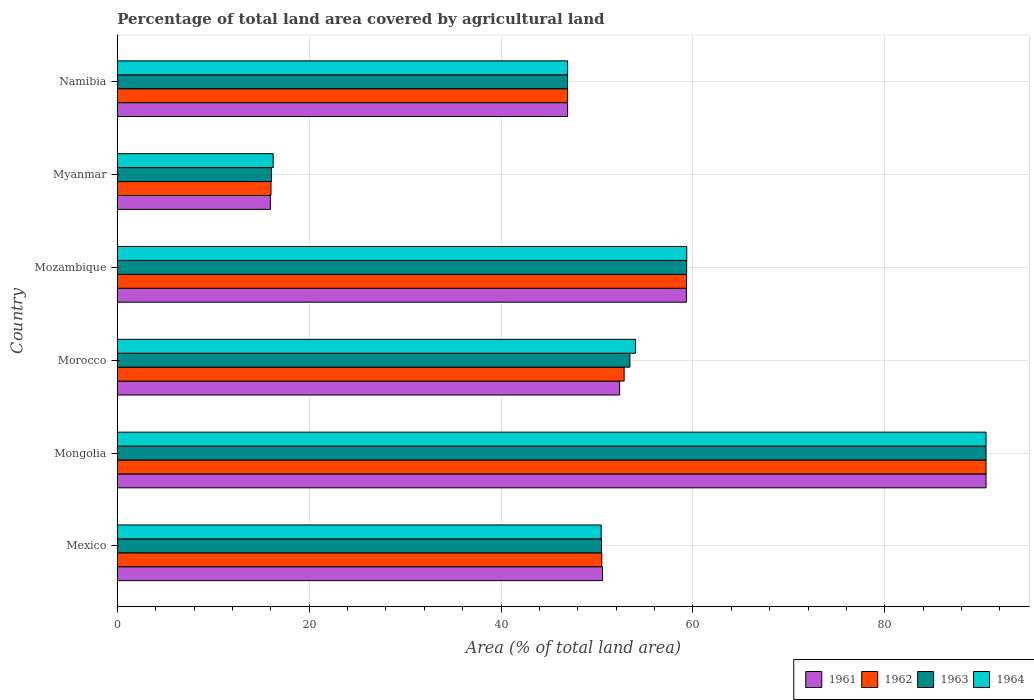How many different coloured bars are there?
Your answer should be very brief. 4. How many groups of bars are there?
Your answer should be very brief. 6. Are the number of bars per tick equal to the number of legend labels?
Your answer should be very brief. Yes. Are the number of bars on each tick of the Y-axis equal?
Provide a short and direct response. Yes. How many bars are there on the 2nd tick from the top?
Your answer should be compact. 4. What is the label of the 2nd group of bars from the top?
Provide a succinct answer. Myanmar. In how many cases, is the number of bars for a given country not equal to the number of legend labels?
Provide a short and direct response. 0. What is the percentage of agricultural land in 1962 in Namibia?
Offer a very short reply. 46.94. Across all countries, what is the maximum percentage of agricultural land in 1962?
Offer a very short reply. 90.56. Across all countries, what is the minimum percentage of agricultural land in 1963?
Your answer should be compact. 16.08. In which country was the percentage of agricultural land in 1962 maximum?
Give a very brief answer. Mongolia. In which country was the percentage of agricultural land in 1962 minimum?
Your response must be concise. Myanmar. What is the total percentage of agricultural land in 1961 in the graph?
Offer a terse response. 315.71. What is the difference between the percentage of agricultural land in 1961 in Mozambique and that in Myanmar?
Ensure brevity in your answer.  43.36. What is the difference between the percentage of agricultural land in 1962 in Mozambique and the percentage of agricultural land in 1961 in Mongolia?
Keep it short and to the point. -31.22. What is the average percentage of agricultural land in 1964 per country?
Your answer should be very brief. 52.93. What is the difference between the percentage of agricultural land in 1962 and percentage of agricultural land in 1961 in Myanmar?
Your response must be concise. 0.06. In how many countries, is the percentage of agricultural land in 1962 greater than 48 %?
Ensure brevity in your answer.  4. What is the ratio of the percentage of agricultural land in 1961 in Mexico to that in Mongolia?
Offer a terse response. 0.56. Is the percentage of agricultural land in 1961 in Mozambique less than that in Myanmar?
Make the answer very short. No. What is the difference between the highest and the second highest percentage of agricultural land in 1964?
Keep it short and to the point. 31.2. What is the difference between the highest and the lowest percentage of agricultural land in 1962?
Your response must be concise. 74.53. What does the 4th bar from the top in Morocco represents?
Keep it short and to the point. 1961. Is it the case that in every country, the sum of the percentage of agricultural land in 1962 and percentage of agricultural land in 1963 is greater than the percentage of agricultural land in 1961?
Your answer should be compact. Yes. Are the values on the major ticks of X-axis written in scientific E-notation?
Offer a very short reply. No. Where does the legend appear in the graph?
Offer a very short reply. Bottom right. How many legend labels are there?
Offer a very short reply. 4. How are the legend labels stacked?
Your response must be concise. Horizontal. What is the title of the graph?
Provide a succinct answer. Percentage of total land area covered by agricultural land. Does "1976" appear as one of the legend labels in the graph?
Ensure brevity in your answer.  No. What is the label or title of the X-axis?
Make the answer very short. Area (% of total land area). What is the Area (% of total land area) in 1961 in Mexico?
Offer a terse response. 50.58. What is the Area (% of total land area) of 1962 in Mexico?
Your response must be concise. 50.5. What is the Area (% of total land area) in 1963 in Mexico?
Ensure brevity in your answer.  50.47. What is the Area (% of total land area) in 1964 in Mexico?
Make the answer very short. 50.44. What is the Area (% of total land area) of 1961 in Mongolia?
Your answer should be compact. 90.56. What is the Area (% of total land area) of 1962 in Mongolia?
Offer a very short reply. 90.56. What is the Area (% of total land area) of 1963 in Mongolia?
Your response must be concise. 90.56. What is the Area (% of total land area) in 1964 in Mongolia?
Make the answer very short. 90.55. What is the Area (% of total land area) of 1961 in Morocco?
Provide a succinct answer. 52.36. What is the Area (% of total land area) in 1962 in Morocco?
Offer a terse response. 52.83. What is the Area (% of total land area) of 1963 in Morocco?
Make the answer very short. 53.43. What is the Area (% of total land area) in 1964 in Morocco?
Give a very brief answer. 54.02. What is the Area (% of total land area) of 1961 in Mozambique?
Provide a short and direct response. 59.32. What is the Area (% of total land area) of 1962 in Mozambique?
Give a very brief answer. 59.34. What is the Area (% of total land area) of 1963 in Mozambique?
Your response must be concise. 59.35. What is the Area (% of total land area) of 1964 in Mozambique?
Your answer should be very brief. 59.36. What is the Area (% of total land area) of 1961 in Myanmar?
Your answer should be compact. 15.96. What is the Area (% of total land area) of 1962 in Myanmar?
Your response must be concise. 16.02. What is the Area (% of total land area) of 1963 in Myanmar?
Offer a terse response. 16.08. What is the Area (% of total land area) of 1964 in Myanmar?
Your answer should be very brief. 16.25. What is the Area (% of total land area) in 1961 in Namibia?
Your answer should be compact. 46.94. What is the Area (% of total land area) in 1962 in Namibia?
Provide a short and direct response. 46.94. What is the Area (% of total land area) in 1963 in Namibia?
Provide a succinct answer. 46.94. What is the Area (% of total land area) of 1964 in Namibia?
Offer a very short reply. 46.94. Across all countries, what is the maximum Area (% of total land area) in 1961?
Offer a very short reply. 90.56. Across all countries, what is the maximum Area (% of total land area) of 1962?
Offer a terse response. 90.56. Across all countries, what is the maximum Area (% of total land area) in 1963?
Offer a terse response. 90.56. Across all countries, what is the maximum Area (% of total land area) in 1964?
Keep it short and to the point. 90.55. Across all countries, what is the minimum Area (% of total land area) of 1961?
Your answer should be very brief. 15.96. Across all countries, what is the minimum Area (% of total land area) of 1962?
Make the answer very short. 16.02. Across all countries, what is the minimum Area (% of total land area) in 1963?
Make the answer very short. 16.08. Across all countries, what is the minimum Area (% of total land area) in 1964?
Keep it short and to the point. 16.25. What is the total Area (% of total land area) of 1961 in the graph?
Your answer should be very brief. 315.71. What is the total Area (% of total land area) in 1962 in the graph?
Provide a succinct answer. 316.18. What is the total Area (% of total land area) of 1963 in the graph?
Make the answer very short. 316.82. What is the total Area (% of total land area) of 1964 in the graph?
Ensure brevity in your answer.  317.56. What is the difference between the Area (% of total land area) of 1961 in Mexico and that in Mongolia?
Ensure brevity in your answer.  -39.98. What is the difference between the Area (% of total land area) of 1962 in Mexico and that in Mongolia?
Your response must be concise. -40.05. What is the difference between the Area (% of total land area) in 1963 in Mexico and that in Mongolia?
Your answer should be very brief. -40.09. What is the difference between the Area (% of total land area) of 1964 in Mexico and that in Mongolia?
Give a very brief answer. -40.12. What is the difference between the Area (% of total land area) in 1961 in Mexico and that in Morocco?
Keep it short and to the point. -1.78. What is the difference between the Area (% of total land area) of 1962 in Mexico and that in Morocco?
Ensure brevity in your answer.  -2.32. What is the difference between the Area (% of total land area) in 1963 in Mexico and that in Morocco?
Your answer should be very brief. -2.97. What is the difference between the Area (% of total land area) of 1964 in Mexico and that in Morocco?
Your response must be concise. -3.58. What is the difference between the Area (% of total land area) in 1961 in Mexico and that in Mozambique?
Your response must be concise. -8.75. What is the difference between the Area (% of total land area) of 1962 in Mexico and that in Mozambique?
Make the answer very short. -8.83. What is the difference between the Area (% of total land area) of 1963 in Mexico and that in Mozambique?
Your answer should be very brief. -8.88. What is the difference between the Area (% of total land area) in 1964 in Mexico and that in Mozambique?
Ensure brevity in your answer.  -8.92. What is the difference between the Area (% of total land area) in 1961 in Mexico and that in Myanmar?
Give a very brief answer. 34.62. What is the difference between the Area (% of total land area) of 1962 in Mexico and that in Myanmar?
Your response must be concise. 34.48. What is the difference between the Area (% of total land area) of 1963 in Mexico and that in Myanmar?
Your response must be concise. 34.39. What is the difference between the Area (% of total land area) in 1964 in Mexico and that in Myanmar?
Provide a succinct answer. 34.19. What is the difference between the Area (% of total land area) of 1961 in Mexico and that in Namibia?
Offer a terse response. 3.64. What is the difference between the Area (% of total land area) of 1962 in Mexico and that in Namibia?
Provide a short and direct response. 3.57. What is the difference between the Area (% of total land area) in 1963 in Mexico and that in Namibia?
Keep it short and to the point. 3.53. What is the difference between the Area (% of total land area) in 1964 in Mexico and that in Namibia?
Your answer should be compact. 3.5. What is the difference between the Area (% of total land area) of 1961 in Mongolia and that in Morocco?
Your response must be concise. 38.2. What is the difference between the Area (% of total land area) of 1962 in Mongolia and that in Morocco?
Ensure brevity in your answer.  37.73. What is the difference between the Area (% of total land area) in 1963 in Mongolia and that in Morocco?
Ensure brevity in your answer.  37.12. What is the difference between the Area (% of total land area) in 1964 in Mongolia and that in Morocco?
Your response must be concise. 36.54. What is the difference between the Area (% of total land area) of 1961 in Mongolia and that in Mozambique?
Your answer should be very brief. 31.23. What is the difference between the Area (% of total land area) in 1962 in Mongolia and that in Mozambique?
Your answer should be compact. 31.22. What is the difference between the Area (% of total land area) in 1963 in Mongolia and that in Mozambique?
Your answer should be compact. 31.21. What is the difference between the Area (% of total land area) in 1964 in Mongolia and that in Mozambique?
Offer a very short reply. 31.2. What is the difference between the Area (% of total land area) in 1961 in Mongolia and that in Myanmar?
Your response must be concise. 74.6. What is the difference between the Area (% of total land area) of 1962 in Mongolia and that in Myanmar?
Offer a terse response. 74.53. What is the difference between the Area (% of total land area) of 1963 in Mongolia and that in Myanmar?
Give a very brief answer. 74.48. What is the difference between the Area (% of total land area) of 1964 in Mongolia and that in Myanmar?
Give a very brief answer. 74.3. What is the difference between the Area (% of total land area) of 1961 in Mongolia and that in Namibia?
Ensure brevity in your answer.  43.62. What is the difference between the Area (% of total land area) of 1962 in Mongolia and that in Namibia?
Ensure brevity in your answer.  43.62. What is the difference between the Area (% of total land area) of 1963 in Mongolia and that in Namibia?
Provide a succinct answer. 43.62. What is the difference between the Area (% of total land area) of 1964 in Mongolia and that in Namibia?
Provide a succinct answer. 43.61. What is the difference between the Area (% of total land area) in 1961 in Morocco and that in Mozambique?
Provide a short and direct response. -6.96. What is the difference between the Area (% of total land area) in 1962 in Morocco and that in Mozambique?
Your answer should be compact. -6.51. What is the difference between the Area (% of total land area) in 1963 in Morocco and that in Mozambique?
Give a very brief answer. -5.91. What is the difference between the Area (% of total land area) of 1964 in Morocco and that in Mozambique?
Offer a very short reply. -5.34. What is the difference between the Area (% of total land area) in 1961 in Morocco and that in Myanmar?
Provide a short and direct response. 36.4. What is the difference between the Area (% of total land area) of 1962 in Morocco and that in Myanmar?
Keep it short and to the point. 36.81. What is the difference between the Area (% of total land area) in 1963 in Morocco and that in Myanmar?
Offer a very short reply. 37.36. What is the difference between the Area (% of total land area) in 1964 in Morocco and that in Myanmar?
Offer a very short reply. 37.77. What is the difference between the Area (% of total land area) of 1961 in Morocco and that in Namibia?
Keep it short and to the point. 5.42. What is the difference between the Area (% of total land area) in 1962 in Morocco and that in Namibia?
Your response must be concise. 5.89. What is the difference between the Area (% of total land area) in 1963 in Morocco and that in Namibia?
Make the answer very short. 6.5. What is the difference between the Area (% of total land area) of 1964 in Morocco and that in Namibia?
Provide a short and direct response. 7.08. What is the difference between the Area (% of total land area) in 1961 in Mozambique and that in Myanmar?
Keep it short and to the point. 43.36. What is the difference between the Area (% of total land area) of 1962 in Mozambique and that in Myanmar?
Ensure brevity in your answer.  43.31. What is the difference between the Area (% of total land area) in 1963 in Mozambique and that in Myanmar?
Provide a succinct answer. 43.27. What is the difference between the Area (% of total land area) in 1964 in Mozambique and that in Myanmar?
Ensure brevity in your answer.  43.11. What is the difference between the Area (% of total land area) of 1961 in Mozambique and that in Namibia?
Your answer should be compact. 12.39. What is the difference between the Area (% of total land area) of 1962 in Mozambique and that in Namibia?
Provide a short and direct response. 12.4. What is the difference between the Area (% of total land area) of 1963 in Mozambique and that in Namibia?
Your response must be concise. 12.41. What is the difference between the Area (% of total land area) of 1964 in Mozambique and that in Namibia?
Your answer should be compact. 12.42. What is the difference between the Area (% of total land area) of 1961 in Myanmar and that in Namibia?
Ensure brevity in your answer.  -30.98. What is the difference between the Area (% of total land area) in 1962 in Myanmar and that in Namibia?
Your answer should be very brief. -30.92. What is the difference between the Area (% of total land area) in 1963 in Myanmar and that in Namibia?
Make the answer very short. -30.86. What is the difference between the Area (% of total land area) of 1964 in Myanmar and that in Namibia?
Provide a succinct answer. -30.69. What is the difference between the Area (% of total land area) in 1961 in Mexico and the Area (% of total land area) in 1962 in Mongolia?
Your answer should be compact. -39.98. What is the difference between the Area (% of total land area) in 1961 in Mexico and the Area (% of total land area) in 1963 in Mongolia?
Offer a terse response. -39.98. What is the difference between the Area (% of total land area) in 1961 in Mexico and the Area (% of total land area) in 1964 in Mongolia?
Provide a succinct answer. -39.98. What is the difference between the Area (% of total land area) in 1962 in Mexico and the Area (% of total land area) in 1963 in Mongolia?
Provide a short and direct response. -40.05. What is the difference between the Area (% of total land area) of 1962 in Mexico and the Area (% of total land area) of 1964 in Mongolia?
Offer a very short reply. -40.05. What is the difference between the Area (% of total land area) in 1963 in Mexico and the Area (% of total land area) in 1964 in Mongolia?
Keep it short and to the point. -40.09. What is the difference between the Area (% of total land area) of 1961 in Mexico and the Area (% of total land area) of 1962 in Morocco?
Provide a succinct answer. -2.25. What is the difference between the Area (% of total land area) in 1961 in Mexico and the Area (% of total land area) in 1963 in Morocco?
Make the answer very short. -2.86. What is the difference between the Area (% of total land area) of 1961 in Mexico and the Area (% of total land area) of 1964 in Morocco?
Keep it short and to the point. -3.44. What is the difference between the Area (% of total land area) in 1962 in Mexico and the Area (% of total land area) in 1963 in Morocco?
Give a very brief answer. -2.93. What is the difference between the Area (% of total land area) of 1962 in Mexico and the Area (% of total land area) of 1964 in Morocco?
Make the answer very short. -3.51. What is the difference between the Area (% of total land area) in 1963 in Mexico and the Area (% of total land area) in 1964 in Morocco?
Offer a very short reply. -3.55. What is the difference between the Area (% of total land area) of 1961 in Mexico and the Area (% of total land area) of 1962 in Mozambique?
Your answer should be very brief. -8.76. What is the difference between the Area (% of total land area) of 1961 in Mexico and the Area (% of total land area) of 1963 in Mozambique?
Your answer should be very brief. -8.77. What is the difference between the Area (% of total land area) of 1961 in Mexico and the Area (% of total land area) of 1964 in Mozambique?
Ensure brevity in your answer.  -8.78. What is the difference between the Area (% of total land area) in 1962 in Mexico and the Area (% of total land area) in 1963 in Mozambique?
Provide a short and direct response. -8.84. What is the difference between the Area (% of total land area) in 1962 in Mexico and the Area (% of total land area) in 1964 in Mozambique?
Give a very brief answer. -8.85. What is the difference between the Area (% of total land area) in 1963 in Mexico and the Area (% of total land area) in 1964 in Mozambique?
Keep it short and to the point. -8.89. What is the difference between the Area (% of total land area) in 1961 in Mexico and the Area (% of total land area) in 1962 in Myanmar?
Provide a short and direct response. 34.55. What is the difference between the Area (% of total land area) of 1961 in Mexico and the Area (% of total land area) of 1963 in Myanmar?
Provide a short and direct response. 34.5. What is the difference between the Area (% of total land area) in 1961 in Mexico and the Area (% of total land area) in 1964 in Myanmar?
Give a very brief answer. 34.33. What is the difference between the Area (% of total land area) of 1962 in Mexico and the Area (% of total land area) of 1963 in Myanmar?
Your answer should be compact. 34.43. What is the difference between the Area (% of total land area) of 1962 in Mexico and the Area (% of total land area) of 1964 in Myanmar?
Your response must be concise. 34.25. What is the difference between the Area (% of total land area) in 1963 in Mexico and the Area (% of total land area) in 1964 in Myanmar?
Your answer should be very brief. 34.22. What is the difference between the Area (% of total land area) of 1961 in Mexico and the Area (% of total land area) of 1962 in Namibia?
Provide a succinct answer. 3.64. What is the difference between the Area (% of total land area) in 1961 in Mexico and the Area (% of total land area) in 1963 in Namibia?
Provide a short and direct response. 3.64. What is the difference between the Area (% of total land area) of 1961 in Mexico and the Area (% of total land area) of 1964 in Namibia?
Give a very brief answer. 3.63. What is the difference between the Area (% of total land area) in 1962 in Mexico and the Area (% of total land area) in 1963 in Namibia?
Provide a succinct answer. 3.57. What is the difference between the Area (% of total land area) in 1962 in Mexico and the Area (% of total land area) in 1964 in Namibia?
Your answer should be compact. 3.56. What is the difference between the Area (% of total land area) of 1963 in Mexico and the Area (% of total land area) of 1964 in Namibia?
Keep it short and to the point. 3.53. What is the difference between the Area (% of total land area) of 1961 in Mongolia and the Area (% of total land area) of 1962 in Morocco?
Your answer should be very brief. 37.73. What is the difference between the Area (% of total land area) in 1961 in Mongolia and the Area (% of total land area) in 1963 in Morocco?
Your response must be concise. 37.12. What is the difference between the Area (% of total land area) of 1961 in Mongolia and the Area (% of total land area) of 1964 in Morocco?
Give a very brief answer. 36.54. What is the difference between the Area (% of total land area) in 1962 in Mongolia and the Area (% of total land area) in 1963 in Morocco?
Provide a succinct answer. 37.12. What is the difference between the Area (% of total land area) in 1962 in Mongolia and the Area (% of total land area) in 1964 in Morocco?
Offer a terse response. 36.54. What is the difference between the Area (% of total land area) in 1963 in Mongolia and the Area (% of total land area) in 1964 in Morocco?
Offer a very short reply. 36.54. What is the difference between the Area (% of total land area) in 1961 in Mongolia and the Area (% of total land area) in 1962 in Mozambique?
Your answer should be very brief. 31.22. What is the difference between the Area (% of total land area) in 1961 in Mongolia and the Area (% of total land area) in 1963 in Mozambique?
Keep it short and to the point. 31.21. What is the difference between the Area (% of total land area) of 1961 in Mongolia and the Area (% of total land area) of 1964 in Mozambique?
Ensure brevity in your answer.  31.2. What is the difference between the Area (% of total land area) in 1962 in Mongolia and the Area (% of total land area) in 1963 in Mozambique?
Keep it short and to the point. 31.21. What is the difference between the Area (% of total land area) of 1962 in Mongolia and the Area (% of total land area) of 1964 in Mozambique?
Ensure brevity in your answer.  31.2. What is the difference between the Area (% of total land area) of 1963 in Mongolia and the Area (% of total land area) of 1964 in Mozambique?
Provide a succinct answer. 31.2. What is the difference between the Area (% of total land area) of 1961 in Mongolia and the Area (% of total land area) of 1962 in Myanmar?
Offer a terse response. 74.53. What is the difference between the Area (% of total land area) in 1961 in Mongolia and the Area (% of total land area) in 1963 in Myanmar?
Make the answer very short. 74.48. What is the difference between the Area (% of total land area) in 1961 in Mongolia and the Area (% of total land area) in 1964 in Myanmar?
Your answer should be compact. 74.31. What is the difference between the Area (% of total land area) in 1962 in Mongolia and the Area (% of total land area) in 1963 in Myanmar?
Give a very brief answer. 74.48. What is the difference between the Area (% of total land area) of 1962 in Mongolia and the Area (% of total land area) of 1964 in Myanmar?
Your response must be concise. 74.31. What is the difference between the Area (% of total land area) in 1963 in Mongolia and the Area (% of total land area) in 1964 in Myanmar?
Offer a very short reply. 74.31. What is the difference between the Area (% of total land area) of 1961 in Mongolia and the Area (% of total land area) of 1962 in Namibia?
Provide a succinct answer. 43.62. What is the difference between the Area (% of total land area) of 1961 in Mongolia and the Area (% of total land area) of 1963 in Namibia?
Provide a short and direct response. 43.62. What is the difference between the Area (% of total land area) in 1961 in Mongolia and the Area (% of total land area) in 1964 in Namibia?
Provide a short and direct response. 43.61. What is the difference between the Area (% of total land area) of 1962 in Mongolia and the Area (% of total land area) of 1963 in Namibia?
Your response must be concise. 43.62. What is the difference between the Area (% of total land area) of 1962 in Mongolia and the Area (% of total land area) of 1964 in Namibia?
Your answer should be compact. 43.61. What is the difference between the Area (% of total land area) in 1963 in Mongolia and the Area (% of total land area) in 1964 in Namibia?
Provide a short and direct response. 43.61. What is the difference between the Area (% of total land area) of 1961 in Morocco and the Area (% of total land area) of 1962 in Mozambique?
Make the answer very short. -6.98. What is the difference between the Area (% of total land area) in 1961 in Morocco and the Area (% of total land area) in 1963 in Mozambique?
Offer a very short reply. -6.99. What is the difference between the Area (% of total land area) in 1961 in Morocco and the Area (% of total land area) in 1964 in Mozambique?
Provide a succinct answer. -7. What is the difference between the Area (% of total land area) of 1962 in Morocco and the Area (% of total land area) of 1963 in Mozambique?
Offer a terse response. -6.52. What is the difference between the Area (% of total land area) of 1962 in Morocco and the Area (% of total land area) of 1964 in Mozambique?
Offer a terse response. -6.53. What is the difference between the Area (% of total land area) in 1963 in Morocco and the Area (% of total land area) in 1964 in Mozambique?
Ensure brevity in your answer.  -5.92. What is the difference between the Area (% of total land area) in 1961 in Morocco and the Area (% of total land area) in 1962 in Myanmar?
Offer a terse response. 36.34. What is the difference between the Area (% of total land area) in 1961 in Morocco and the Area (% of total land area) in 1963 in Myanmar?
Your response must be concise. 36.28. What is the difference between the Area (% of total land area) of 1961 in Morocco and the Area (% of total land area) of 1964 in Myanmar?
Ensure brevity in your answer.  36.11. What is the difference between the Area (% of total land area) in 1962 in Morocco and the Area (% of total land area) in 1963 in Myanmar?
Offer a very short reply. 36.75. What is the difference between the Area (% of total land area) in 1962 in Morocco and the Area (% of total land area) in 1964 in Myanmar?
Keep it short and to the point. 36.58. What is the difference between the Area (% of total land area) in 1963 in Morocco and the Area (% of total land area) in 1964 in Myanmar?
Your response must be concise. 37.18. What is the difference between the Area (% of total land area) in 1961 in Morocco and the Area (% of total land area) in 1962 in Namibia?
Your answer should be compact. 5.42. What is the difference between the Area (% of total land area) in 1961 in Morocco and the Area (% of total land area) in 1963 in Namibia?
Keep it short and to the point. 5.42. What is the difference between the Area (% of total land area) of 1961 in Morocco and the Area (% of total land area) of 1964 in Namibia?
Give a very brief answer. 5.42. What is the difference between the Area (% of total land area) of 1962 in Morocco and the Area (% of total land area) of 1963 in Namibia?
Ensure brevity in your answer.  5.89. What is the difference between the Area (% of total land area) of 1962 in Morocco and the Area (% of total land area) of 1964 in Namibia?
Provide a short and direct response. 5.89. What is the difference between the Area (% of total land area) in 1963 in Morocco and the Area (% of total land area) in 1964 in Namibia?
Keep it short and to the point. 6.49. What is the difference between the Area (% of total land area) of 1961 in Mozambique and the Area (% of total land area) of 1962 in Myanmar?
Keep it short and to the point. 43.3. What is the difference between the Area (% of total land area) of 1961 in Mozambique and the Area (% of total land area) of 1963 in Myanmar?
Give a very brief answer. 43.24. What is the difference between the Area (% of total land area) in 1961 in Mozambique and the Area (% of total land area) in 1964 in Myanmar?
Ensure brevity in your answer.  43.07. What is the difference between the Area (% of total land area) of 1962 in Mozambique and the Area (% of total land area) of 1963 in Myanmar?
Offer a very short reply. 43.26. What is the difference between the Area (% of total land area) of 1962 in Mozambique and the Area (% of total land area) of 1964 in Myanmar?
Your response must be concise. 43.09. What is the difference between the Area (% of total land area) of 1963 in Mozambique and the Area (% of total land area) of 1964 in Myanmar?
Your answer should be compact. 43.1. What is the difference between the Area (% of total land area) in 1961 in Mozambique and the Area (% of total land area) in 1962 in Namibia?
Offer a very short reply. 12.39. What is the difference between the Area (% of total land area) in 1961 in Mozambique and the Area (% of total land area) in 1963 in Namibia?
Keep it short and to the point. 12.39. What is the difference between the Area (% of total land area) in 1961 in Mozambique and the Area (% of total land area) in 1964 in Namibia?
Make the answer very short. 12.38. What is the difference between the Area (% of total land area) in 1962 in Mozambique and the Area (% of total land area) in 1963 in Namibia?
Offer a very short reply. 12.4. What is the difference between the Area (% of total land area) of 1962 in Mozambique and the Area (% of total land area) of 1964 in Namibia?
Your response must be concise. 12.39. What is the difference between the Area (% of total land area) in 1963 in Mozambique and the Area (% of total land area) in 1964 in Namibia?
Your response must be concise. 12.41. What is the difference between the Area (% of total land area) in 1961 in Myanmar and the Area (% of total land area) in 1962 in Namibia?
Provide a short and direct response. -30.98. What is the difference between the Area (% of total land area) of 1961 in Myanmar and the Area (% of total land area) of 1963 in Namibia?
Make the answer very short. -30.98. What is the difference between the Area (% of total land area) of 1961 in Myanmar and the Area (% of total land area) of 1964 in Namibia?
Keep it short and to the point. -30.98. What is the difference between the Area (% of total land area) in 1962 in Myanmar and the Area (% of total land area) in 1963 in Namibia?
Make the answer very short. -30.92. What is the difference between the Area (% of total land area) in 1962 in Myanmar and the Area (% of total land area) in 1964 in Namibia?
Ensure brevity in your answer.  -30.92. What is the difference between the Area (% of total land area) in 1963 in Myanmar and the Area (% of total land area) in 1964 in Namibia?
Your answer should be very brief. -30.86. What is the average Area (% of total land area) in 1961 per country?
Offer a terse response. 52.62. What is the average Area (% of total land area) of 1962 per country?
Offer a terse response. 52.7. What is the average Area (% of total land area) in 1963 per country?
Provide a short and direct response. 52.8. What is the average Area (% of total land area) in 1964 per country?
Offer a very short reply. 52.93. What is the difference between the Area (% of total land area) of 1961 and Area (% of total land area) of 1962 in Mexico?
Provide a succinct answer. 0.07. What is the difference between the Area (% of total land area) in 1961 and Area (% of total land area) in 1963 in Mexico?
Give a very brief answer. 0.11. What is the difference between the Area (% of total land area) in 1961 and Area (% of total land area) in 1964 in Mexico?
Ensure brevity in your answer.  0.14. What is the difference between the Area (% of total land area) of 1962 and Area (% of total land area) of 1963 in Mexico?
Ensure brevity in your answer.  0.04. What is the difference between the Area (% of total land area) of 1962 and Area (% of total land area) of 1964 in Mexico?
Ensure brevity in your answer.  0.07. What is the difference between the Area (% of total land area) in 1963 and Area (% of total land area) in 1964 in Mexico?
Keep it short and to the point. 0.03. What is the difference between the Area (% of total land area) of 1961 and Area (% of total land area) of 1964 in Mongolia?
Your response must be concise. 0. What is the difference between the Area (% of total land area) in 1962 and Area (% of total land area) in 1963 in Mongolia?
Your answer should be very brief. 0. What is the difference between the Area (% of total land area) of 1962 and Area (% of total land area) of 1964 in Mongolia?
Offer a terse response. 0. What is the difference between the Area (% of total land area) of 1963 and Area (% of total land area) of 1964 in Mongolia?
Ensure brevity in your answer.  0. What is the difference between the Area (% of total land area) of 1961 and Area (% of total land area) of 1962 in Morocco?
Make the answer very short. -0.47. What is the difference between the Area (% of total land area) in 1961 and Area (% of total land area) in 1963 in Morocco?
Offer a terse response. -1.08. What is the difference between the Area (% of total land area) in 1961 and Area (% of total land area) in 1964 in Morocco?
Offer a very short reply. -1.66. What is the difference between the Area (% of total land area) in 1962 and Area (% of total land area) in 1963 in Morocco?
Offer a very short reply. -0.6. What is the difference between the Area (% of total land area) in 1962 and Area (% of total land area) in 1964 in Morocco?
Ensure brevity in your answer.  -1.19. What is the difference between the Area (% of total land area) in 1963 and Area (% of total land area) in 1964 in Morocco?
Make the answer very short. -0.58. What is the difference between the Area (% of total land area) in 1961 and Area (% of total land area) in 1962 in Mozambique?
Your answer should be compact. -0.01. What is the difference between the Area (% of total land area) of 1961 and Area (% of total land area) of 1963 in Mozambique?
Make the answer very short. -0.03. What is the difference between the Area (% of total land area) of 1961 and Area (% of total land area) of 1964 in Mozambique?
Keep it short and to the point. -0.04. What is the difference between the Area (% of total land area) in 1962 and Area (% of total land area) in 1963 in Mozambique?
Provide a succinct answer. -0.01. What is the difference between the Area (% of total land area) of 1962 and Area (% of total land area) of 1964 in Mozambique?
Give a very brief answer. -0.02. What is the difference between the Area (% of total land area) of 1963 and Area (% of total land area) of 1964 in Mozambique?
Provide a succinct answer. -0.01. What is the difference between the Area (% of total land area) of 1961 and Area (% of total land area) of 1962 in Myanmar?
Your response must be concise. -0.06. What is the difference between the Area (% of total land area) in 1961 and Area (% of total land area) in 1963 in Myanmar?
Provide a short and direct response. -0.12. What is the difference between the Area (% of total land area) in 1961 and Area (% of total land area) in 1964 in Myanmar?
Make the answer very short. -0.29. What is the difference between the Area (% of total land area) of 1962 and Area (% of total land area) of 1963 in Myanmar?
Provide a short and direct response. -0.06. What is the difference between the Area (% of total land area) of 1962 and Area (% of total land area) of 1964 in Myanmar?
Your answer should be very brief. -0.23. What is the difference between the Area (% of total land area) of 1963 and Area (% of total land area) of 1964 in Myanmar?
Your response must be concise. -0.17. What is the difference between the Area (% of total land area) of 1961 and Area (% of total land area) of 1963 in Namibia?
Provide a short and direct response. 0. What is the difference between the Area (% of total land area) in 1961 and Area (% of total land area) in 1964 in Namibia?
Your answer should be very brief. -0. What is the difference between the Area (% of total land area) in 1962 and Area (% of total land area) in 1963 in Namibia?
Give a very brief answer. 0. What is the difference between the Area (% of total land area) in 1962 and Area (% of total land area) in 1964 in Namibia?
Offer a terse response. -0. What is the difference between the Area (% of total land area) in 1963 and Area (% of total land area) in 1964 in Namibia?
Give a very brief answer. -0. What is the ratio of the Area (% of total land area) of 1961 in Mexico to that in Mongolia?
Give a very brief answer. 0.56. What is the ratio of the Area (% of total land area) of 1962 in Mexico to that in Mongolia?
Your answer should be compact. 0.56. What is the ratio of the Area (% of total land area) in 1963 in Mexico to that in Mongolia?
Offer a terse response. 0.56. What is the ratio of the Area (% of total land area) of 1964 in Mexico to that in Mongolia?
Your answer should be compact. 0.56. What is the ratio of the Area (% of total land area) in 1961 in Mexico to that in Morocco?
Offer a terse response. 0.97. What is the ratio of the Area (% of total land area) in 1962 in Mexico to that in Morocco?
Offer a terse response. 0.96. What is the ratio of the Area (% of total land area) in 1963 in Mexico to that in Morocco?
Your answer should be compact. 0.94. What is the ratio of the Area (% of total land area) in 1964 in Mexico to that in Morocco?
Your answer should be very brief. 0.93. What is the ratio of the Area (% of total land area) of 1961 in Mexico to that in Mozambique?
Give a very brief answer. 0.85. What is the ratio of the Area (% of total land area) of 1962 in Mexico to that in Mozambique?
Your answer should be very brief. 0.85. What is the ratio of the Area (% of total land area) of 1963 in Mexico to that in Mozambique?
Ensure brevity in your answer.  0.85. What is the ratio of the Area (% of total land area) in 1964 in Mexico to that in Mozambique?
Offer a terse response. 0.85. What is the ratio of the Area (% of total land area) in 1961 in Mexico to that in Myanmar?
Your answer should be compact. 3.17. What is the ratio of the Area (% of total land area) in 1962 in Mexico to that in Myanmar?
Your answer should be compact. 3.15. What is the ratio of the Area (% of total land area) in 1963 in Mexico to that in Myanmar?
Give a very brief answer. 3.14. What is the ratio of the Area (% of total land area) of 1964 in Mexico to that in Myanmar?
Offer a very short reply. 3.1. What is the ratio of the Area (% of total land area) in 1961 in Mexico to that in Namibia?
Provide a succinct answer. 1.08. What is the ratio of the Area (% of total land area) of 1962 in Mexico to that in Namibia?
Ensure brevity in your answer.  1.08. What is the ratio of the Area (% of total land area) in 1963 in Mexico to that in Namibia?
Your response must be concise. 1.08. What is the ratio of the Area (% of total land area) of 1964 in Mexico to that in Namibia?
Provide a succinct answer. 1.07. What is the ratio of the Area (% of total land area) in 1961 in Mongolia to that in Morocco?
Ensure brevity in your answer.  1.73. What is the ratio of the Area (% of total land area) in 1962 in Mongolia to that in Morocco?
Offer a terse response. 1.71. What is the ratio of the Area (% of total land area) in 1963 in Mongolia to that in Morocco?
Give a very brief answer. 1.69. What is the ratio of the Area (% of total land area) in 1964 in Mongolia to that in Morocco?
Give a very brief answer. 1.68. What is the ratio of the Area (% of total land area) in 1961 in Mongolia to that in Mozambique?
Your answer should be very brief. 1.53. What is the ratio of the Area (% of total land area) in 1962 in Mongolia to that in Mozambique?
Your response must be concise. 1.53. What is the ratio of the Area (% of total land area) of 1963 in Mongolia to that in Mozambique?
Offer a terse response. 1.53. What is the ratio of the Area (% of total land area) in 1964 in Mongolia to that in Mozambique?
Your answer should be compact. 1.53. What is the ratio of the Area (% of total land area) of 1961 in Mongolia to that in Myanmar?
Offer a terse response. 5.67. What is the ratio of the Area (% of total land area) of 1962 in Mongolia to that in Myanmar?
Ensure brevity in your answer.  5.65. What is the ratio of the Area (% of total land area) in 1963 in Mongolia to that in Myanmar?
Your answer should be very brief. 5.63. What is the ratio of the Area (% of total land area) in 1964 in Mongolia to that in Myanmar?
Make the answer very short. 5.57. What is the ratio of the Area (% of total land area) in 1961 in Mongolia to that in Namibia?
Your answer should be compact. 1.93. What is the ratio of the Area (% of total land area) in 1962 in Mongolia to that in Namibia?
Keep it short and to the point. 1.93. What is the ratio of the Area (% of total land area) of 1963 in Mongolia to that in Namibia?
Your answer should be very brief. 1.93. What is the ratio of the Area (% of total land area) in 1964 in Mongolia to that in Namibia?
Offer a very short reply. 1.93. What is the ratio of the Area (% of total land area) in 1961 in Morocco to that in Mozambique?
Make the answer very short. 0.88. What is the ratio of the Area (% of total land area) in 1962 in Morocco to that in Mozambique?
Provide a succinct answer. 0.89. What is the ratio of the Area (% of total land area) of 1963 in Morocco to that in Mozambique?
Offer a very short reply. 0.9. What is the ratio of the Area (% of total land area) of 1964 in Morocco to that in Mozambique?
Offer a very short reply. 0.91. What is the ratio of the Area (% of total land area) of 1961 in Morocco to that in Myanmar?
Provide a short and direct response. 3.28. What is the ratio of the Area (% of total land area) in 1962 in Morocco to that in Myanmar?
Offer a very short reply. 3.3. What is the ratio of the Area (% of total land area) of 1963 in Morocco to that in Myanmar?
Offer a very short reply. 3.32. What is the ratio of the Area (% of total land area) in 1964 in Morocco to that in Myanmar?
Offer a terse response. 3.32. What is the ratio of the Area (% of total land area) of 1961 in Morocco to that in Namibia?
Offer a very short reply. 1.12. What is the ratio of the Area (% of total land area) of 1962 in Morocco to that in Namibia?
Provide a succinct answer. 1.13. What is the ratio of the Area (% of total land area) in 1963 in Morocco to that in Namibia?
Keep it short and to the point. 1.14. What is the ratio of the Area (% of total land area) in 1964 in Morocco to that in Namibia?
Provide a short and direct response. 1.15. What is the ratio of the Area (% of total land area) in 1961 in Mozambique to that in Myanmar?
Make the answer very short. 3.72. What is the ratio of the Area (% of total land area) of 1962 in Mozambique to that in Myanmar?
Offer a very short reply. 3.7. What is the ratio of the Area (% of total land area) in 1963 in Mozambique to that in Myanmar?
Your answer should be compact. 3.69. What is the ratio of the Area (% of total land area) in 1964 in Mozambique to that in Myanmar?
Provide a short and direct response. 3.65. What is the ratio of the Area (% of total land area) in 1961 in Mozambique to that in Namibia?
Your answer should be very brief. 1.26. What is the ratio of the Area (% of total land area) of 1962 in Mozambique to that in Namibia?
Offer a terse response. 1.26. What is the ratio of the Area (% of total land area) of 1963 in Mozambique to that in Namibia?
Offer a very short reply. 1.26. What is the ratio of the Area (% of total land area) of 1964 in Mozambique to that in Namibia?
Your answer should be compact. 1.26. What is the ratio of the Area (% of total land area) in 1961 in Myanmar to that in Namibia?
Offer a very short reply. 0.34. What is the ratio of the Area (% of total land area) of 1962 in Myanmar to that in Namibia?
Offer a terse response. 0.34. What is the ratio of the Area (% of total land area) in 1963 in Myanmar to that in Namibia?
Your answer should be compact. 0.34. What is the ratio of the Area (% of total land area) in 1964 in Myanmar to that in Namibia?
Your answer should be very brief. 0.35. What is the difference between the highest and the second highest Area (% of total land area) of 1961?
Provide a succinct answer. 31.23. What is the difference between the highest and the second highest Area (% of total land area) of 1962?
Provide a short and direct response. 31.22. What is the difference between the highest and the second highest Area (% of total land area) of 1963?
Ensure brevity in your answer.  31.21. What is the difference between the highest and the second highest Area (% of total land area) in 1964?
Offer a very short reply. 31.2. What is the difference between the highest and the lowest Area (% of total land area) in 1961?
Your response must be concise. 74.6. What is the difference between the highest and the lowest Area (% of total land area) of 1962?
Your response must be concise. 74.53. What is the difference between the highest and the lowest Area (% of total land area) of 1963?
Make the answer very short. 74.48. What is the difference between the highest and the lowest Area (% of total land area) of 1964?
Your answer should be compact. 74.3. 